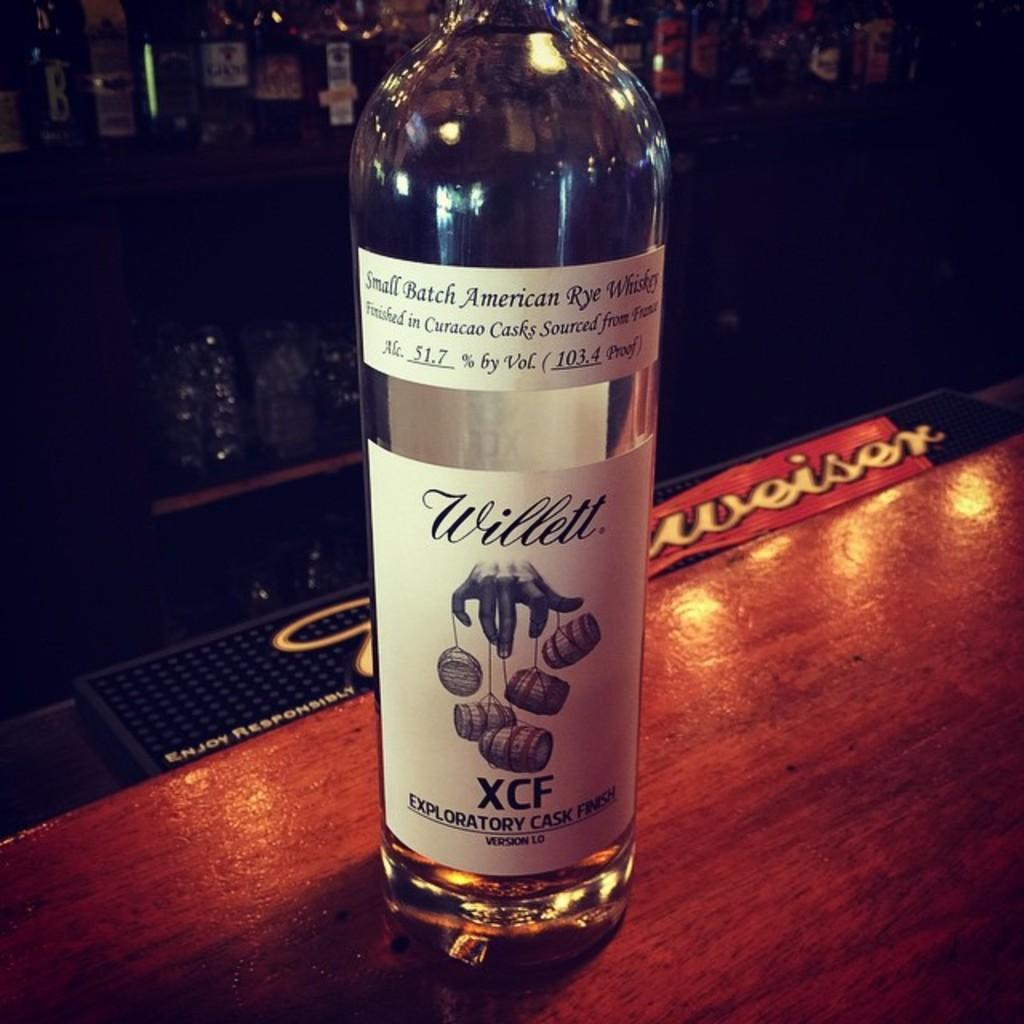<image>
Describe the image concisely. Large bottle of alcohol named Willett on top of a counter. 